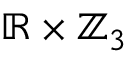Convert formula to latex. <formula><loc_0><loc_0><loc_500><loc_500>\mathbb { R } \times \mathbb { Z } _ { 3 }</formula> 